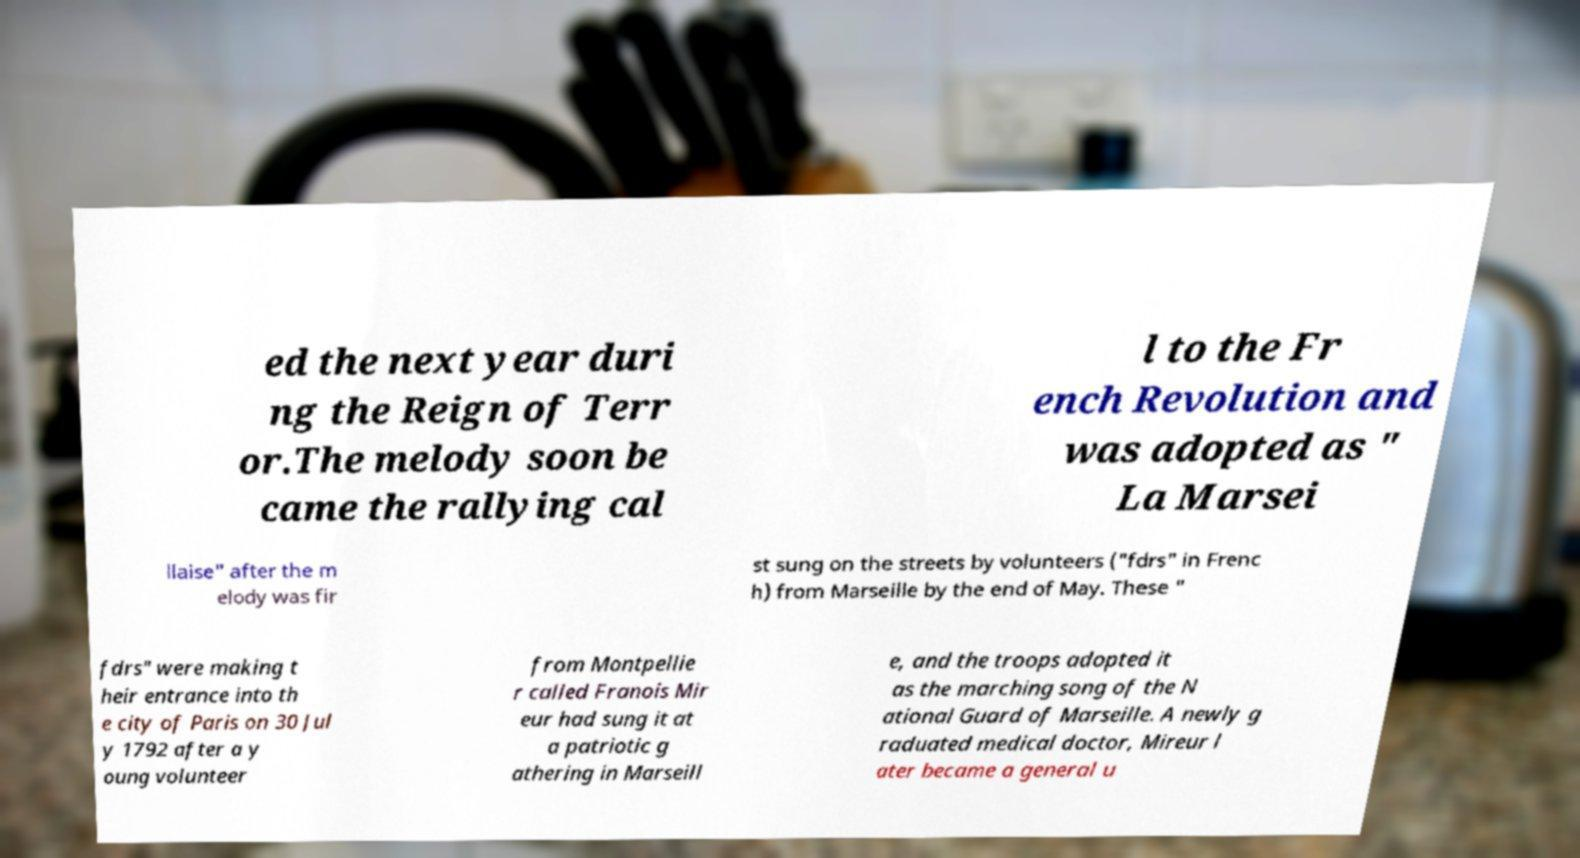Could you assist in decoding the text presented in this image and type it out clearly? ed the next year duri ng the Reign of Terr or.The melody soon be came the rallying cal l to the Fr ench Revolution and was adopted as " La Marsei llaise" after the m elody was fir st sung on the streets by volunteers ("fdrs" in Frenc h) from Marseille by the end of May. These " fdrs" were making t heir entrance into th e city of Paris on 30 Jul y 1792 after a y oung volunteer from Montpellie r called Franois Mir eur had sung it at a patriotic g athering in Marseill e, and the troops adopted it as the marching song of the N ational Guard of Marseille. A newly g raduated medical doctor, Mireur l ater became a general u 